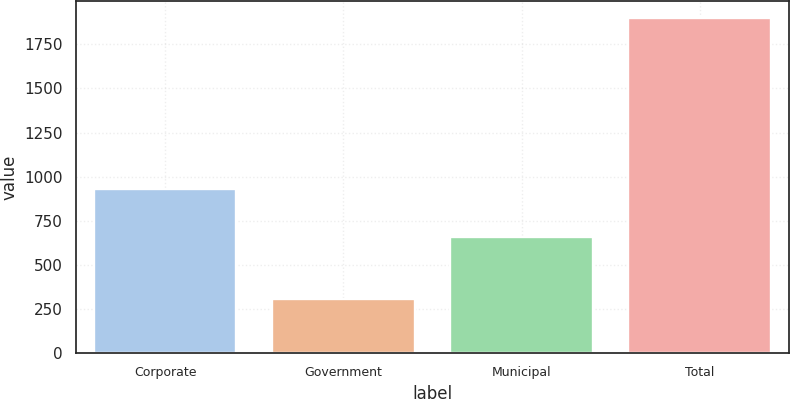Convert chart. <chart><loc_0><loc_0><loc_500><loc_500><bar_chart><fcel>Corporate<fcel>Government<fcel>Municipal<fcel>Total<nl><fcel>932<fcel>309<fcel>659<fcel>1900<nl></chart> 